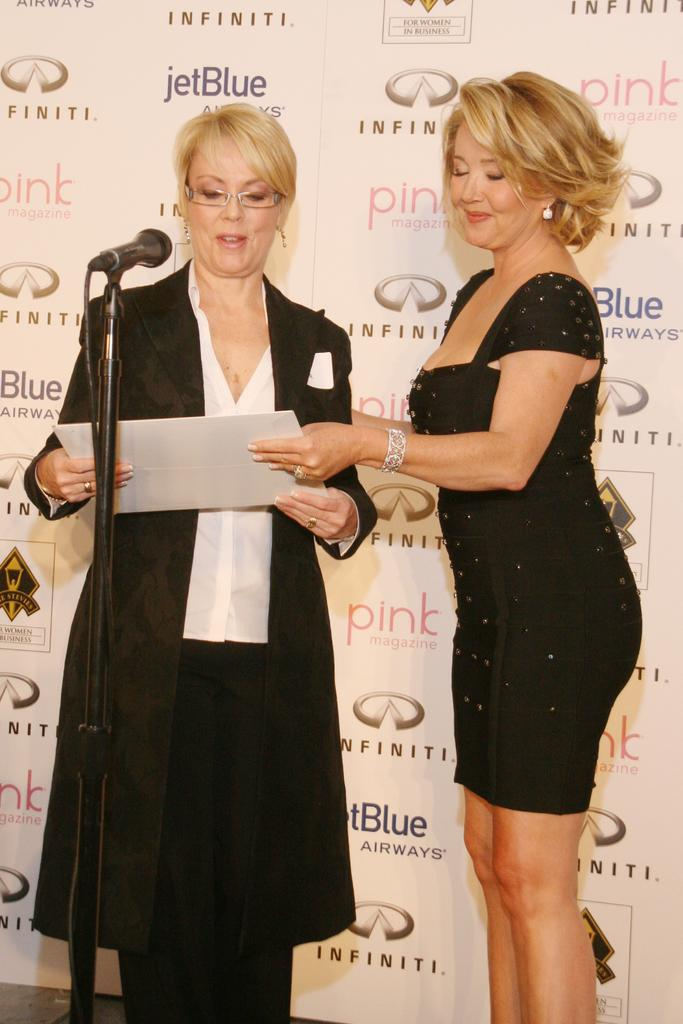How many people are in the image? There are two women standing in the image. What object can be seen on the left side of the image? A microphone is present on the left side of the image. What can be seen in the background of the image? There are logos visible in the background of the image. What type of drain is visible in the image? There is no drain present in the image. What kind of oatmeal is being served to the women in the image? There is no oatmeal or food visible in the image. 